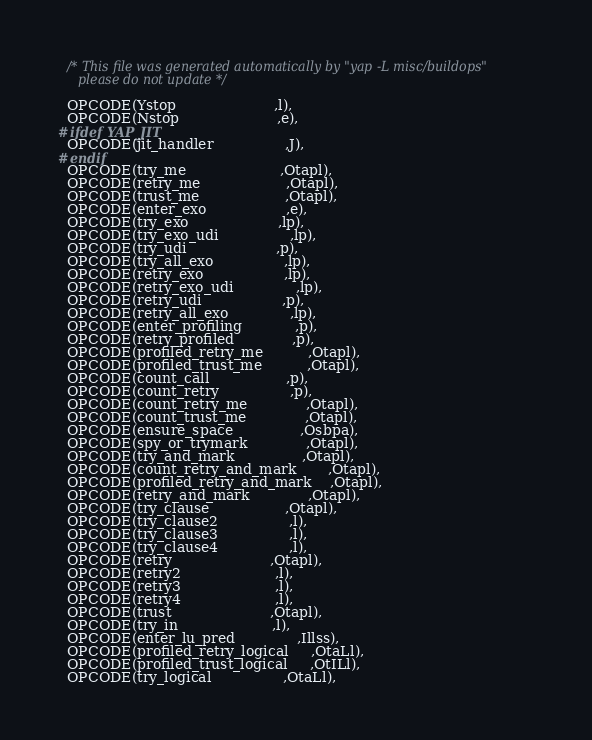<code> <loc_0><loc_0><loc_500><loc_500><_C_>
  /* This file was generated automatically by "yap -L misc/buildops"
     please do not update */

  OPCODE(Ystop                      ,l),
  OPCODE(Nstop                      ,e),
#ifdef YAP_JIT
  OPCODE(jit_handler                ,J),
#endif
  OPCODE(try_me                     ,Otapl),
  OPCODE(retry_me                   ,Otapl),
  OPCODE(trust_me                   ,Otapl),
  OPCODE(enter_exo                  ,e),
  OPCODE(try_exo                    ,lp),
  OPCODE(try_exo_udi                ,lp),
  OPCODE(try_udi                    ,p),
  OPCODE(try_all_exo                ,lp),
  OPCODE(retry_exo                  ,lp),
  OPCODE(retry_exo_udi              ,lp),
  OPCODE(retry_udi                  ,p),
  OPCODE(retry_all_exo              ,lp),
  OPCODE(enter_profiling            ,p),
  OPCODE(retry_profiled             ,p),
  OPCODE(profiled_retry_me          ,Otapl),
  OPCODE(profiled_trust_me          ,Otapl),
  OPCODE(count_call                 ,p),
  OPCODE(count_retry                ,p),
  OPCODE(count_retry_me             ,Otapl),
  OPCODE(count_trust_me             ,Otapl),
  OPCODE(ensure_space               ,Osbpa),
  OPCODE(spy_or_trymark             ,Otapl),
  OPCODE(try_and_mark               ,Otapl),
  OPCODE(count_retry_and_mark       ,Otapl),
  OPCODE(profiled_retry_and_mark    ,Otapl),
  OPCODE(retry_and_mark             ,Otapl),
  OPCODE(try_clause                 ,Otapl),
  OPCODE(try_clause2                ,l),
  OPCODE(try_clause3                ,l),
  OPCODE(try_clause4                ,l),
  OPCODE(retry                      ,Otapl),
  OPCODE(retry2                     ,l),
  OPCODE(retry3                     ,l),
  OPCODE(retry4                     ,l),
  OPCODE(trust                      ,Otapl),
  OPCODE(try_in                     ,l),
  OPCODE(enter_lu_pred              ,Illss),
  OPCODE(profiled_retry_logical     ,OtaLl),
  OPCODE(profiled_trust_logical     ,OtILl),
  OPCODE(try_logical                ,OtaLl),</code> 